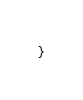Convert code to text. <code><loc_0><loc_0><loc_500><loc_500><_Java_>
}
</code> 